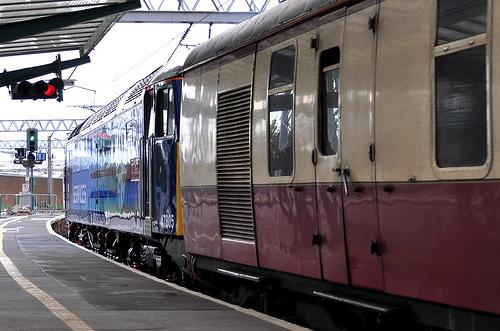Point out an interesting detail about the train in the image. The train has a vent on its side, adding a unique element to the image. Describe the overall setting of the image, including the train and traffic lights. The image features a passenger train making a turn on train tracks, with traffic lights, a red one hanging on the roof and a green one further away, and a concrete pavement nearby. Spot a traffic light in the image and describe its color and placement. There is a red traffic light hanging on the roof, and a green traffic light further in the background. Provide a brief description of the most prominent object in the image. A passenger train making a turn appears as the dominant subject in the image. Describe any features on the train, such as windows or doors. The train has a tightly locked coach door and several windows visible on its side. What is the color of the waiting bay roof, and what else can be seen near it? The waiting bay roof is grey, and there are signal lights hanging from it along with power lines passing above. Mention the color of the train and its location in the scene. The train is red and white, and it is located on the train tracks, making a turn. Describe the colors and aspects of the pavement near the train tracks. The pavement near the train tracks is grey with white and yellow lines and features a pole and a signal light. Describe the type and state of the train cars seen in the image. Two cars of a train are visible, which are double cabin coaches, one with a red and white color and the other blue. Mention something interesting about the train's door and its surroundings. The train's door has a handle, and there is a window visible on both sides of it. 